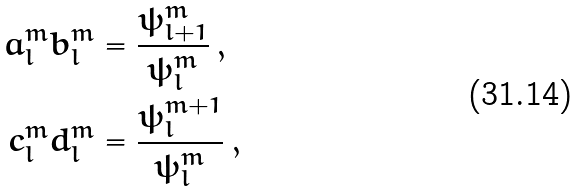Convert formula to latex. <formula><loc_0><loc_0><loc_500><loc_500>a _ { l } ^ { m } b _ { l } ^ { m } & = \frac { \psi _ { l + 1 } ^ { m } } { \psi _ { l } ^ { m } } \, , \\ c _ { l } ^ { m } d _ { l } ^ { m } & = \frac { \psi _ { l } ^ { m + 1 } } { \psi _ { l } ^ { m } } \, ,</formula> 